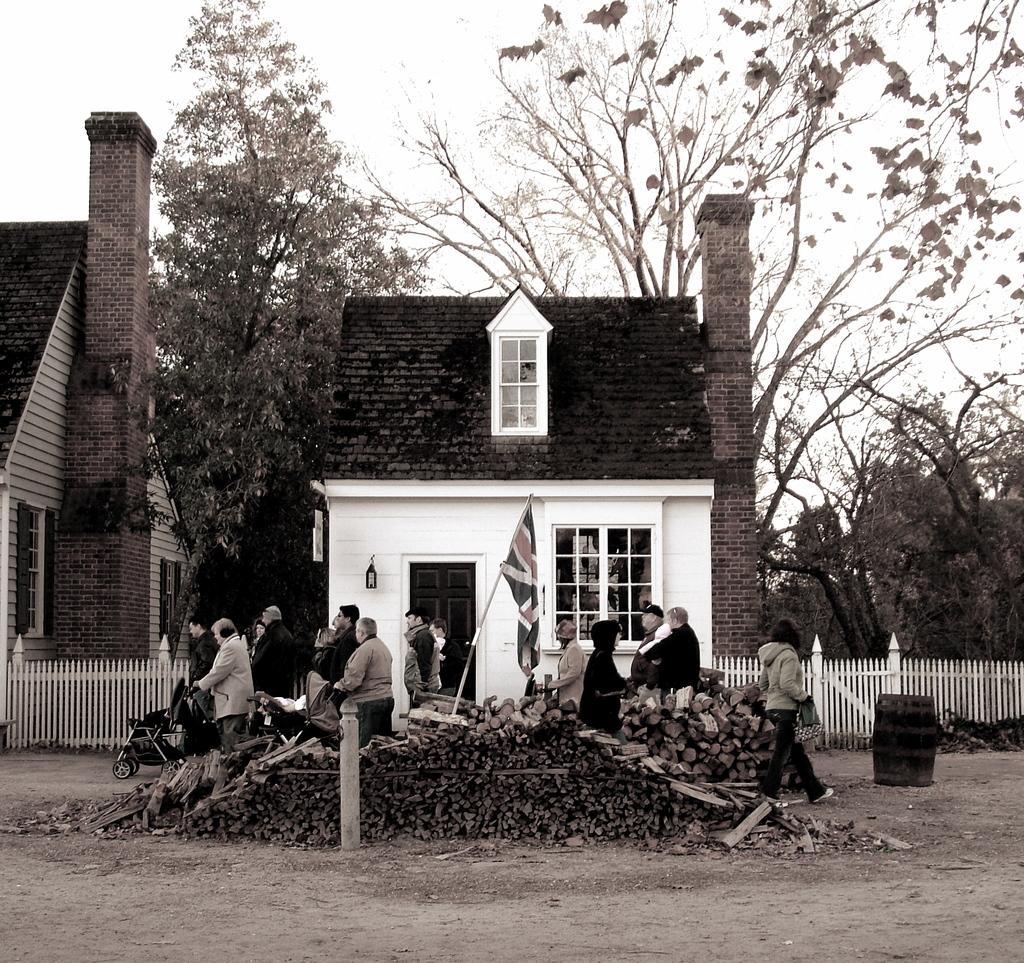In one or two sentences, can you explain what this image depicts? In the center of the image there is a house, flag and wooden sticks. On the left side of the image we can see tree, house, fencing and persons on the road. On the right side we can see trees, fencing and person on the road. In the background there is a sky. 